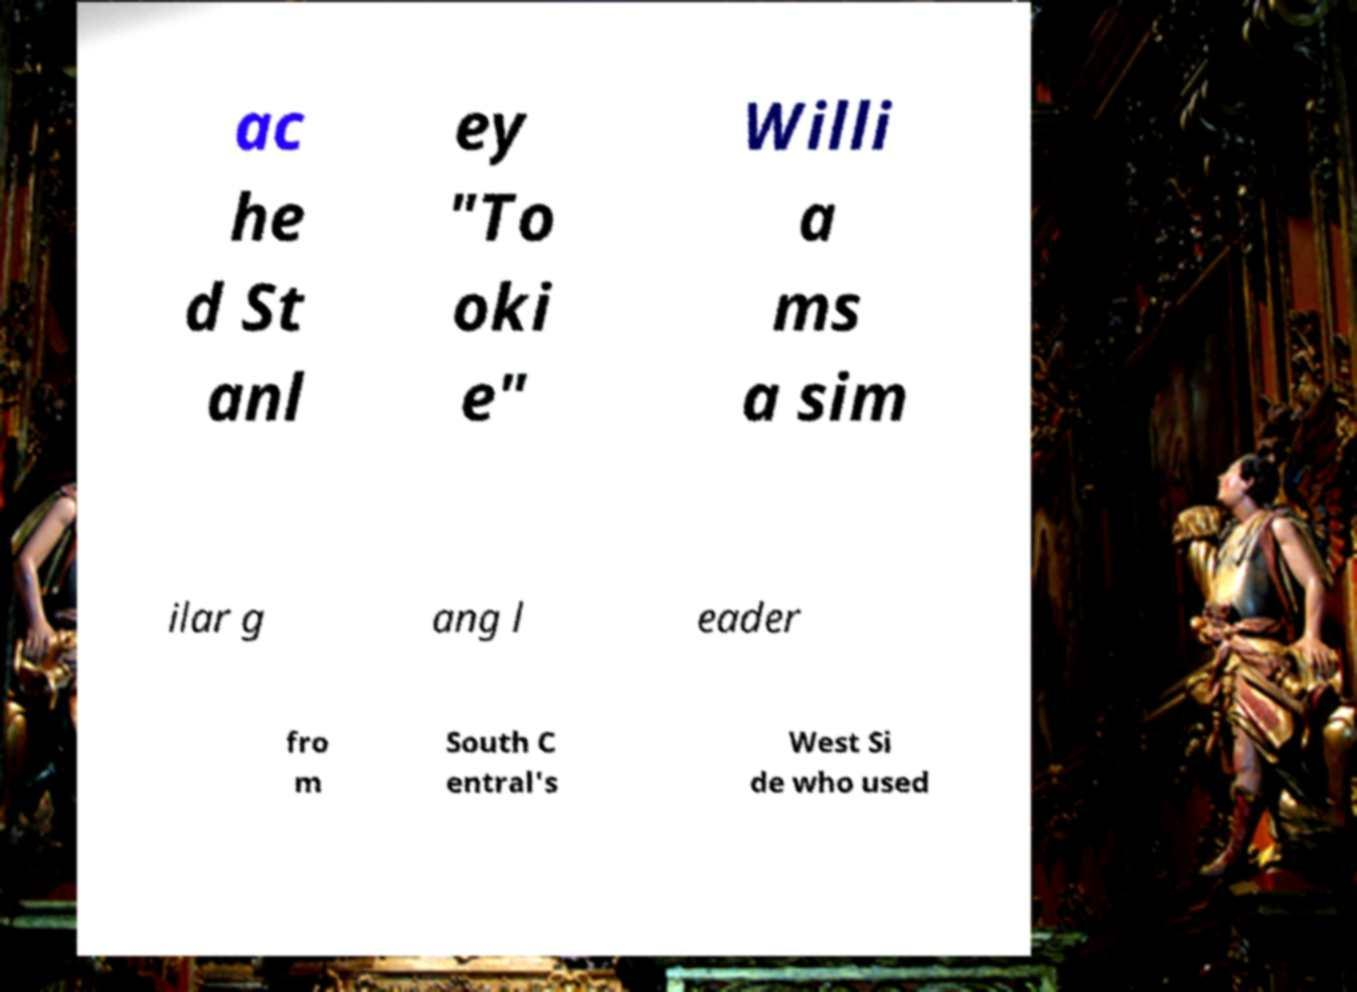Can you accurately transcribe the text from the provided image for me? ac he d St anl ey "To oki e" Willi a ms a sim ilar g ang l eader fro m South C entral's West Si de who used 